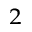Convert formula to latex. <formula><loc_0><loc_0><loc_500><loc_500>^ { 2 }</formula> 